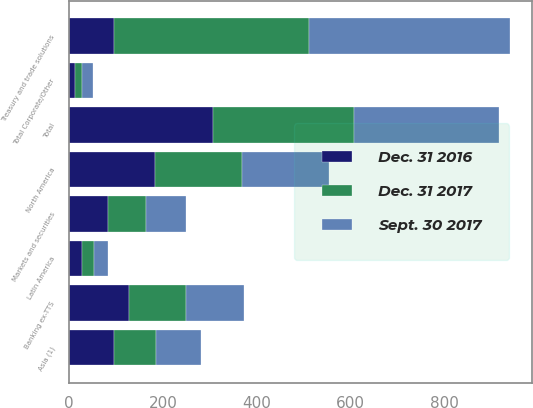<chart> <loc_0><loc_0><loc_500><loc_500><stacked_bar_chart><ecel><fcel>North America<fcel>Latin America<fcel>Asia (1)<fcel>Total<fcel>Treasury and trade solutions<fcel>Banking ex-TTS<fcel>Markets and securities<fcel>Total Corporate/Other<nl><fcel>Dec. 31 2016<fcel>182.7<fcel>27.8<fcel>96<fcel>306.5<fcel>96<fcel>126.9<fcel>82.9<fcel>12.4<nl><fcel>Sept. 30 2017<fcel>184.1<fcel>28.8<fcel>95.2<fcel>308.1<fcel>427.8<fcel>122.4<fcel>84.7<fcel>22.9<nl><fcel>Dec. 31 2017<fcel>186<fcel>25.2<fcel>89.9<fcel>301.1<fcel>415.4<fcel>122.4<fcel>81.7<fcel>14.6<nl></chart> 